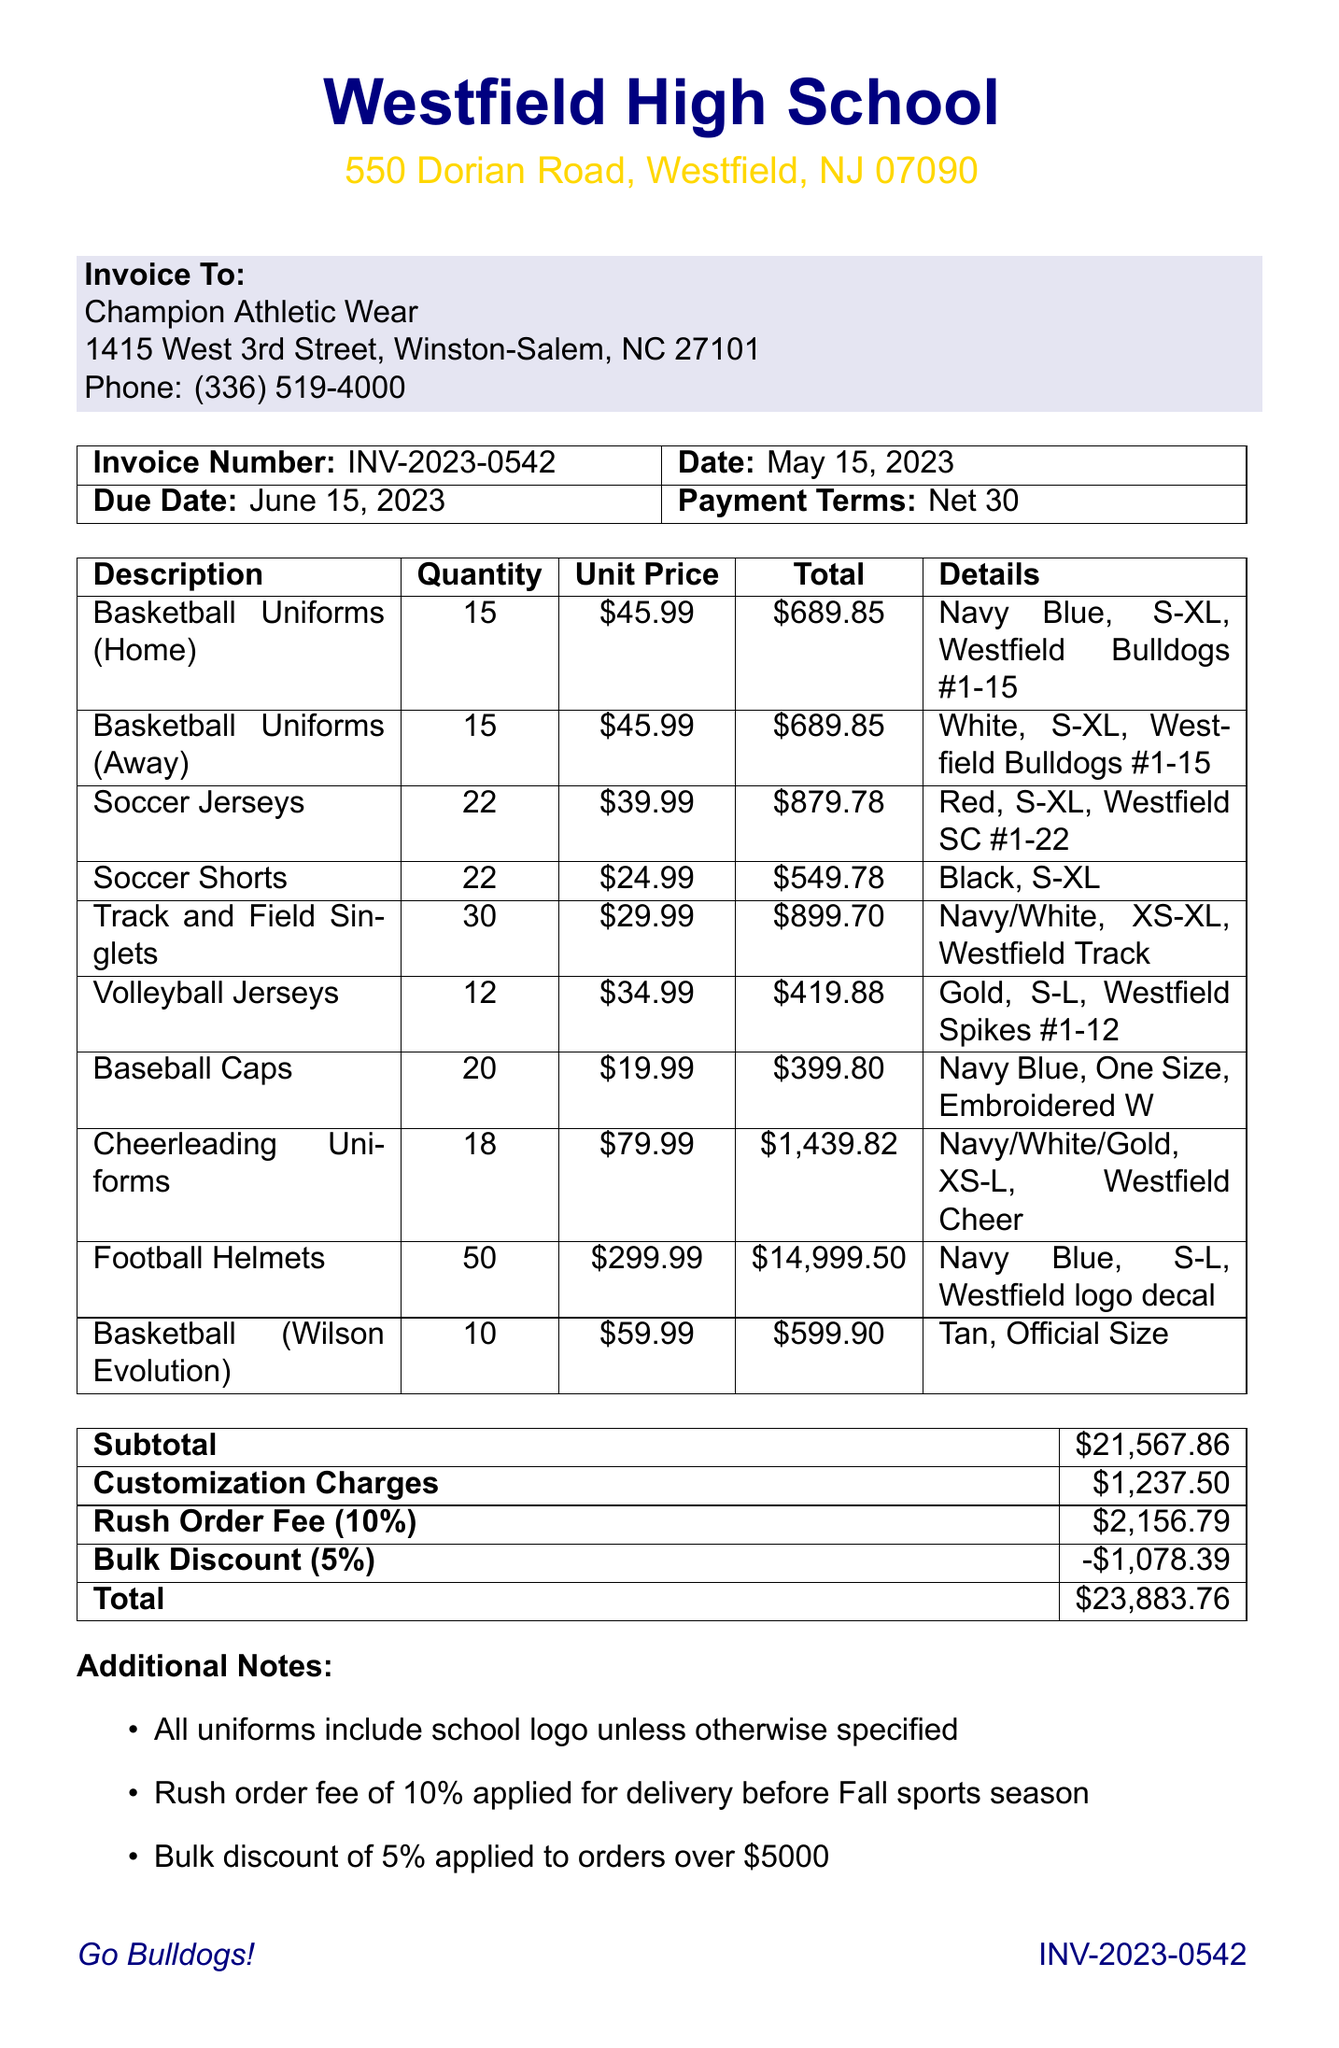What is the invoice number? The invoice number is listed at the top of the document in the invoice details section.
Answer: INV-2023-0542 What is the due date for this invoice? The due date can be found in the invoice details section of the document.
Answer: June 15, 2023 How many Basketball Uniforms (Home) were ordered? The quantity of Basketball Uniforms (Home) is specified in the items list in the document.
Answer: 15 What is the unit price of the Cheerleading Uniforms? The unit price for Cheerleading Uniforms is presented in the items section of the invoice.
Answer: $79.99 What is the total cost for Soccer Jerseys? The total cost is calculated based on the quantity and unit price of Soccer Jerseys, which is shown in the items list.
Answer: $879.78 What type of shipping method is used? The shipping method is provided in the additional notes section of the document.
Answer: UPS Ground What was the bulk discount applied? The bulk discount amount is mentioned in the summary table, indicating their discount policy on large orders.
Answer: -$1,078.39 What is the total amount due for this invoice? The total is presented in the summary table, which aggregates all charges and discounts.
Answer: $23,883.76 How many items were ordered in total? To find the total number of items ordered, you need to sum the quantity for all items listed in the invoice.
Answer: 206 